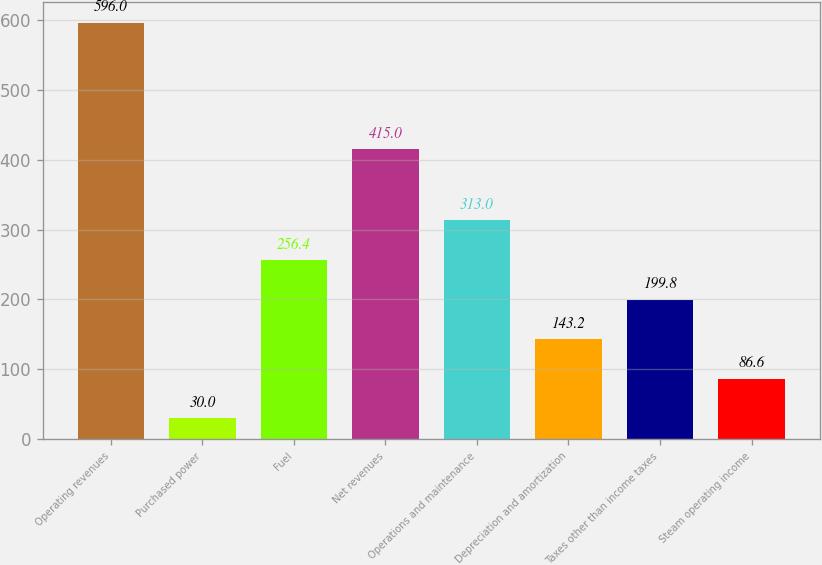Convert chart. <chart><loc_0><loc_0><loc_500><loc_500><bar_chart><fcel>Operating revenues<fcel>Purchased power<fcel>Fuel<fcel>Net revenues<fcel>Operations and maintenance<fcel>Depreciation and amortization<fcel>Taxes other than income taxes<fcel>Steam operating income<nl><fcel>596<fcel>30<fcel>256.4<fcel>415<fcel>313<fcel>143.2<fcel>199.8<fcel>86.6<nl></chart> 